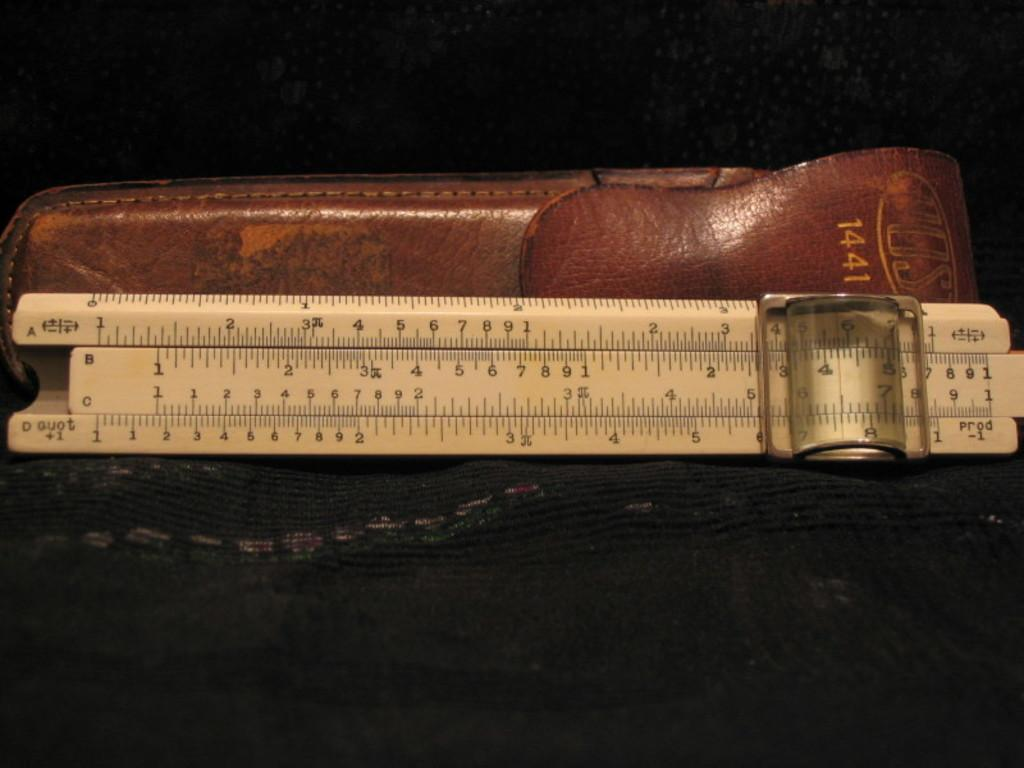Provide a one-sentence caption for the provided image. An old model 1441 Vost sliding scale ruler with leather pouch. 